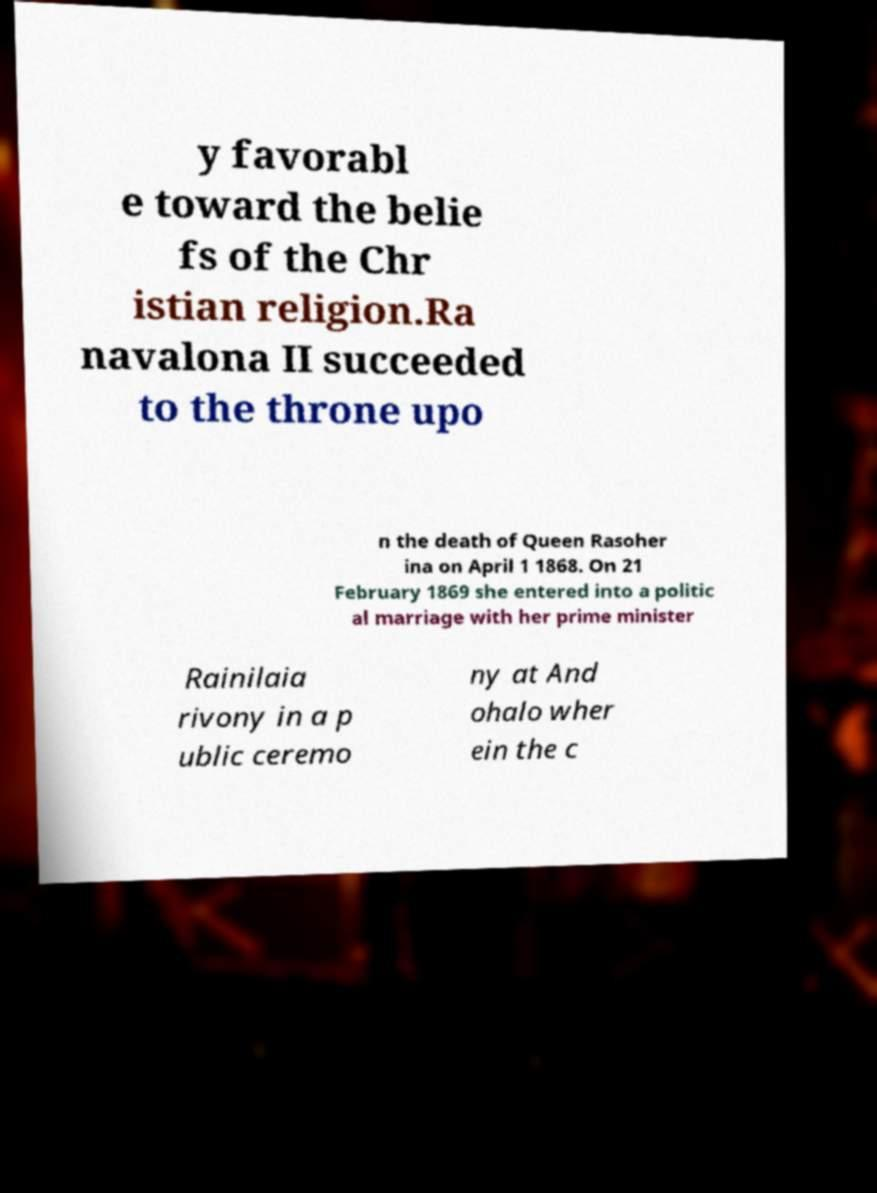Can you accurately transcribe the text from the provided image for me? y favorabl e toward the belie fs of the Chr istian religion.Ra navalona II succeeded to the throne upo n the death of Queen Rasoher ina on April 1 1868. On 21 February 1869 she entered into a politic al marriage with her prime minister Rainilaia rivony in a p ublic ceremo ny at And ohalo wher ein the c 